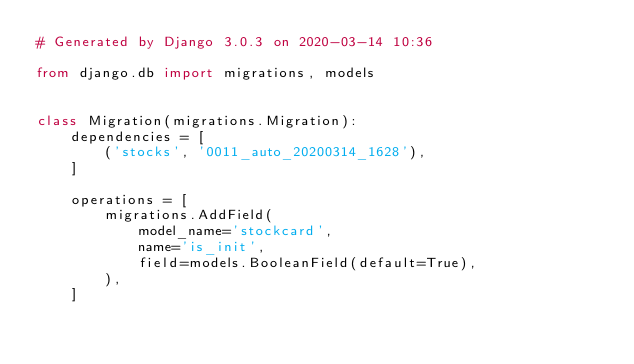Convert code to text. <code><loc_0><loc_0><loc_500><loc_500><_Python_># Generated by Django 3.0.3 on 2020-03-14 10:36

from django.db import migrations, models


class Migration(migrations.Migration):
    dependencies = [
        ('stocks', '0011_auto_20200314_1628'),
    ]

    operations = [
        migrations.AddField(
            model_name='stockcard',
            name='is_init',
            field=models.BooleanField(default=True),
        ),
    ]
</code> 